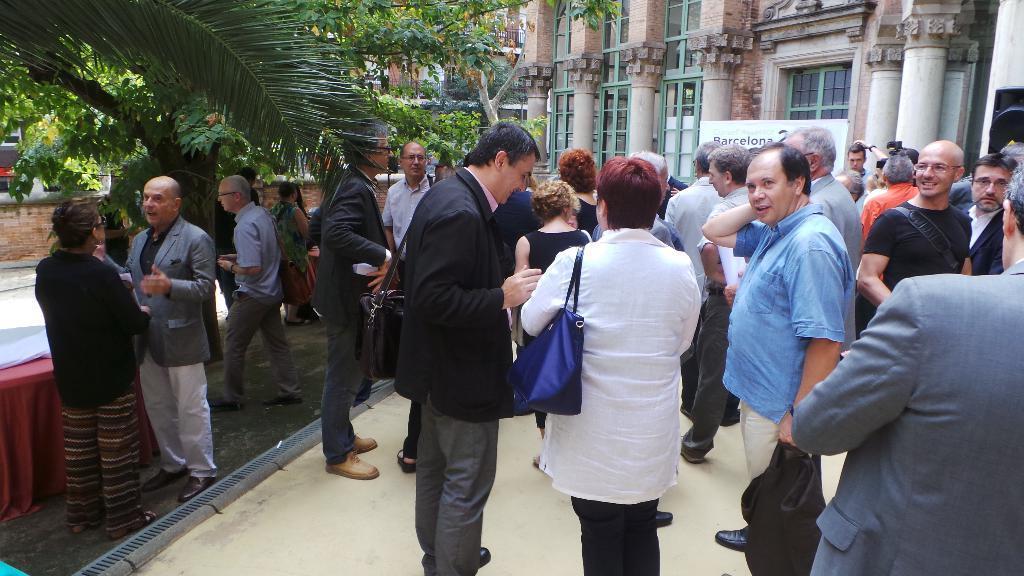In one or two sentences, can you explain what this image depicts? In the center of the image we can see people standing. In the background there are buildings and we can see a board. On the left there are trees and there is a table. 